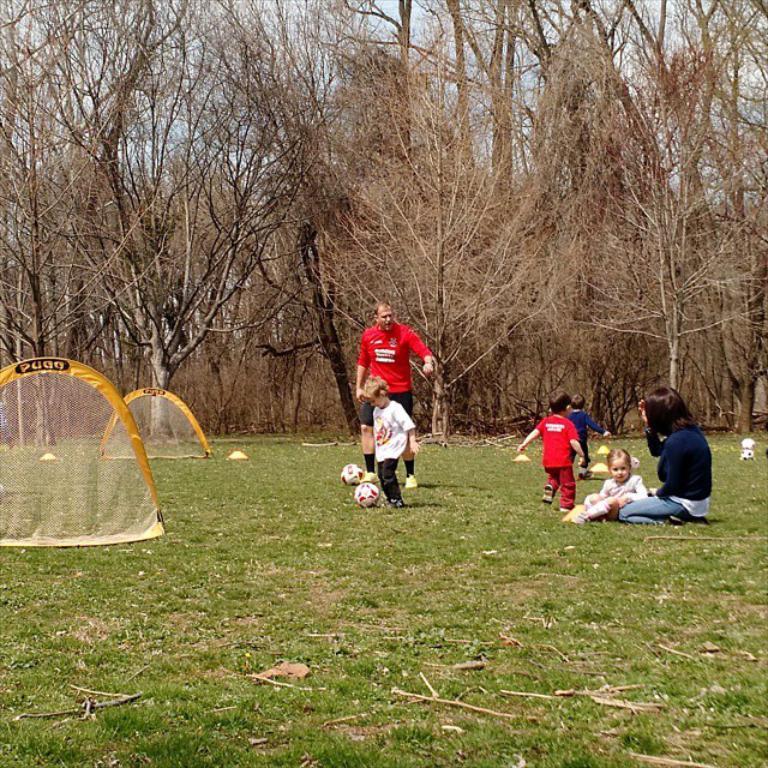Please provide a concise description of this image. This picture shows a man standing and three boys playing with the ball and we see a woman and a girl seated and we see trees and a green grass 